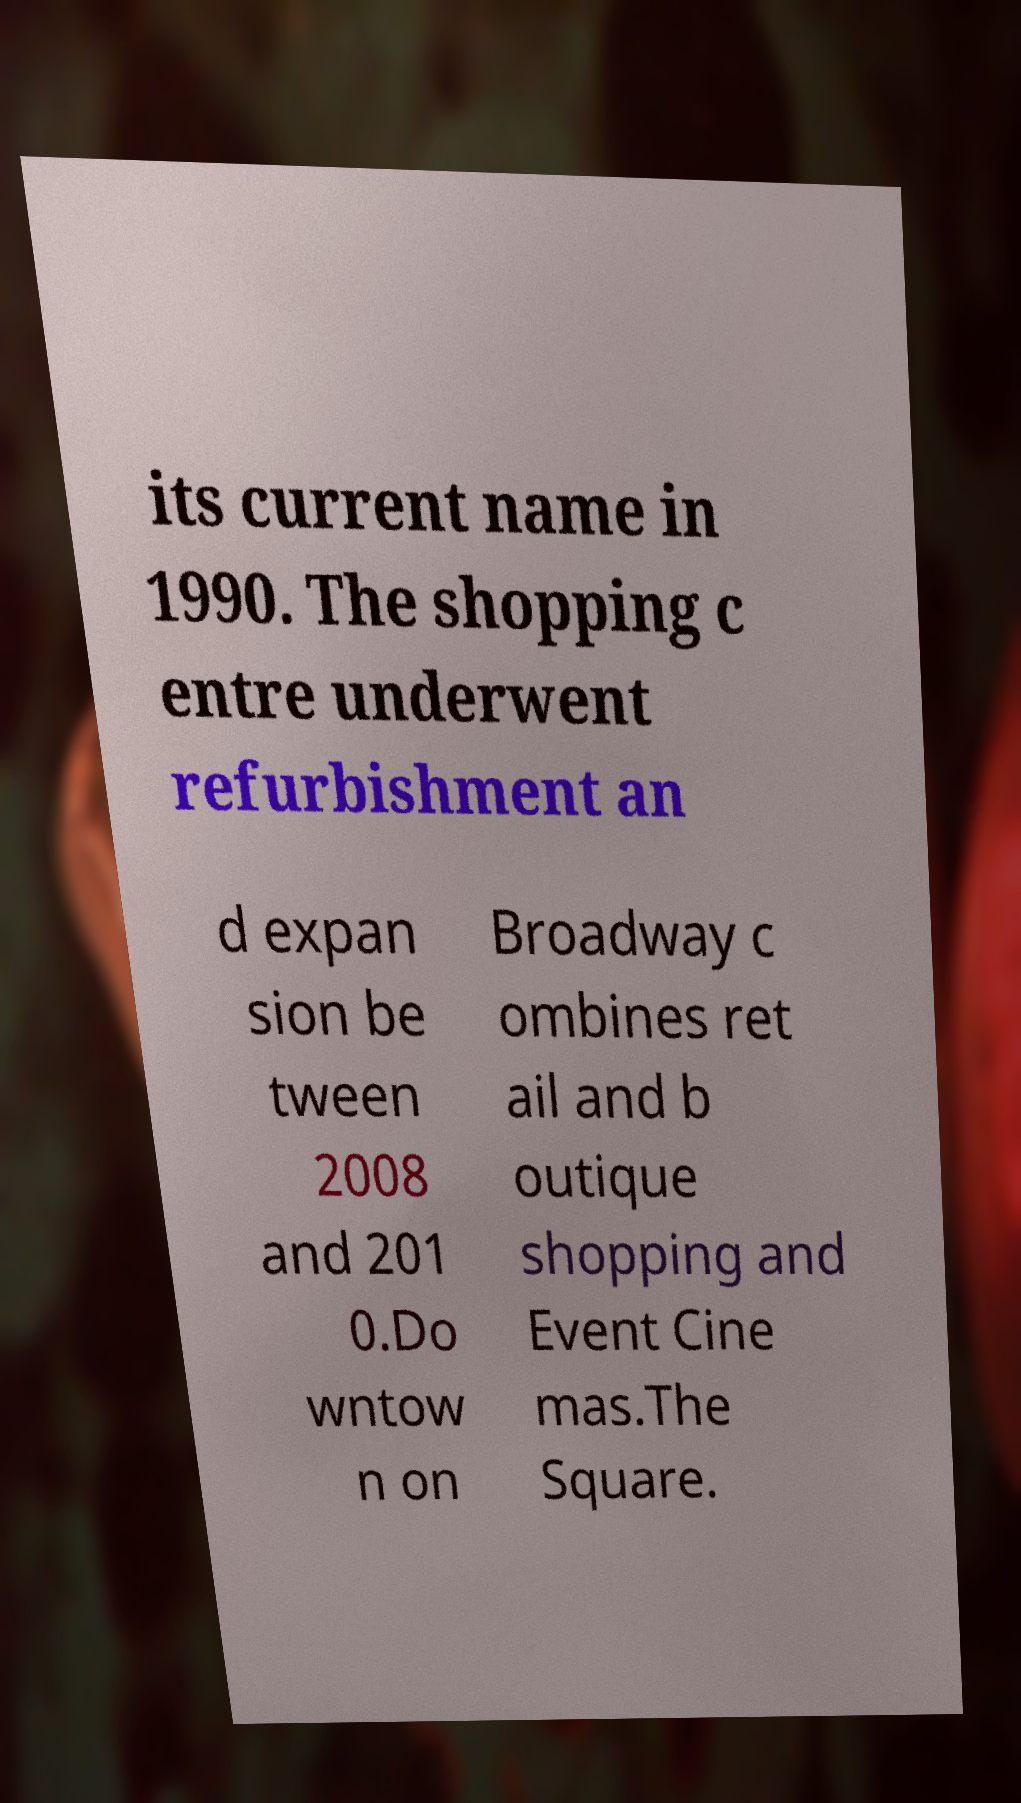What messages or text are displayed in this image? I need them in a readable, typed format. its current name in 1990. The shopping c entre underwent refurbishment an d expan sion be tween 2008 and 201 0.Do wntow n on Broadway c ombines ret ail and b outique shopping and Event Cine mas.The Square. 